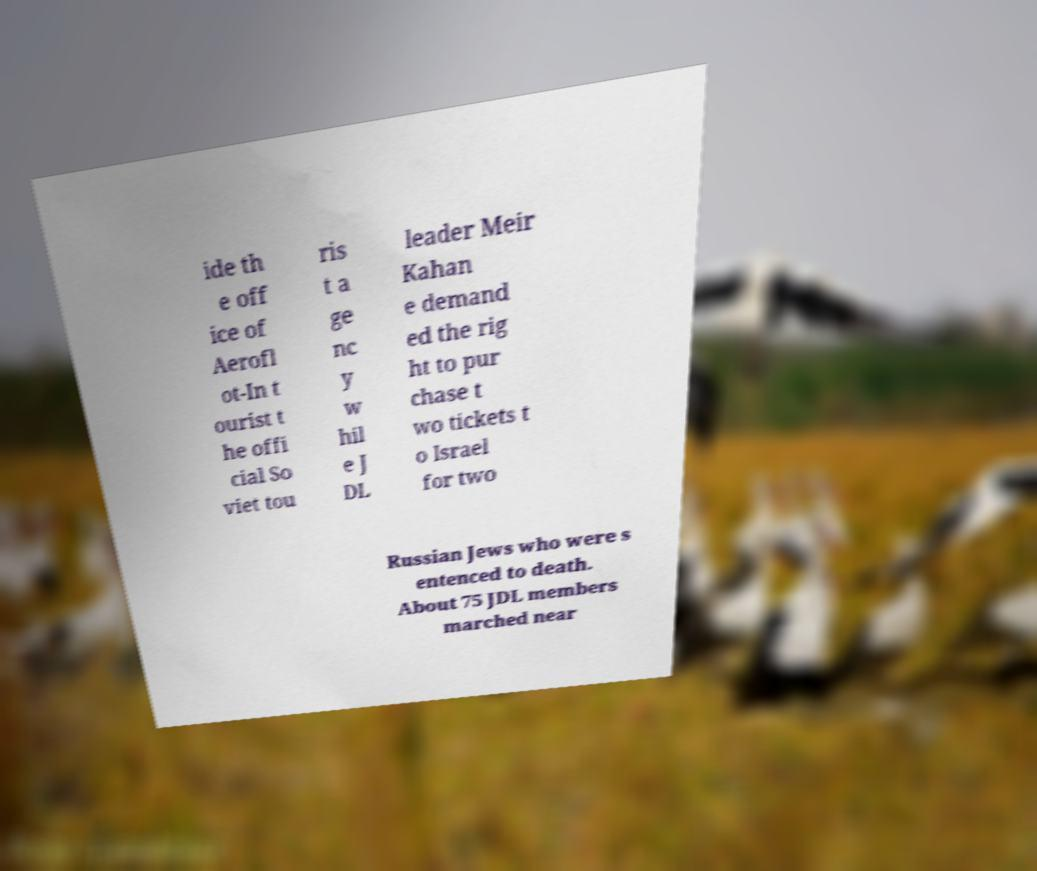Could you extract and type out the text from this image? ide th e off ice of Aerofl ot-In t ourist t he offi cial So viet tou ris t a ge nc y w hil e J DL leader Meir Kahan e demand ed the rig ht to pur chase t wo tickets t o Israel for two Russian Jews who were s entenced to death. About 75 JDL members marched near 